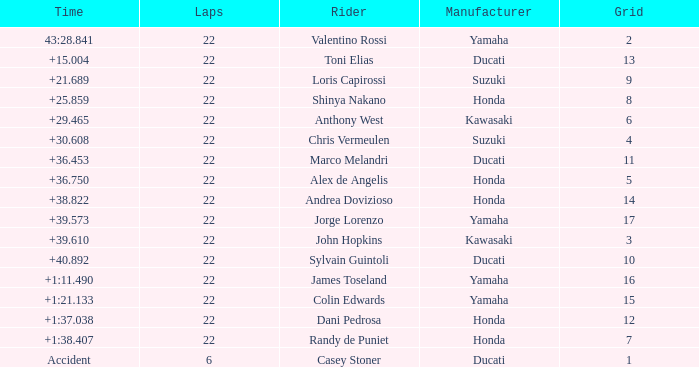What laps did Honda do with a time of +1:38.407? 22.0. 